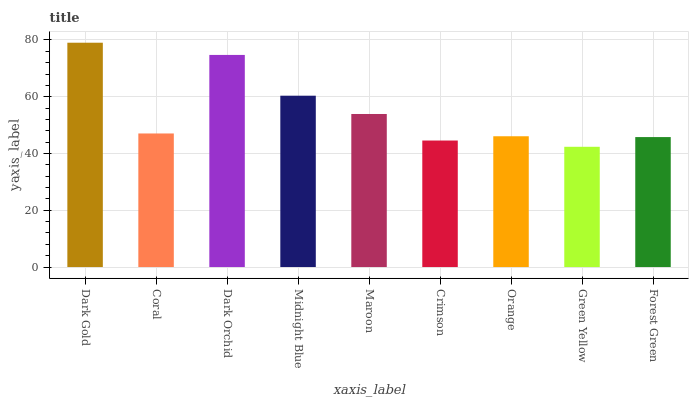Is Green Yellow the minimum?
Answer yes or no. Yes. Is Dark Gold the maximum?
Answer yes or no. Yes. Is Coral the minimum?
Answer yes or no. No. Is Coral the maximum?
Answer yes or no. No. Is Dark Gold greater than Coral?
Answer yes or no. Yes. Is Coral less than Dark Gold?
Answer yes or no. Yes. Is Coral greater than Dark Gold?
Answer yes or no. No. Is Dark Gold less than Coral?
Answer yes or no. No. Is Coral the high median?
Answer yes or no. Yes. Is Coral the low median?
Answer yes or no. Yes. Is Green Yellow the high median?
Answer yes or no. No. Is Forest Green the low median?
Answer yes or no. No. 